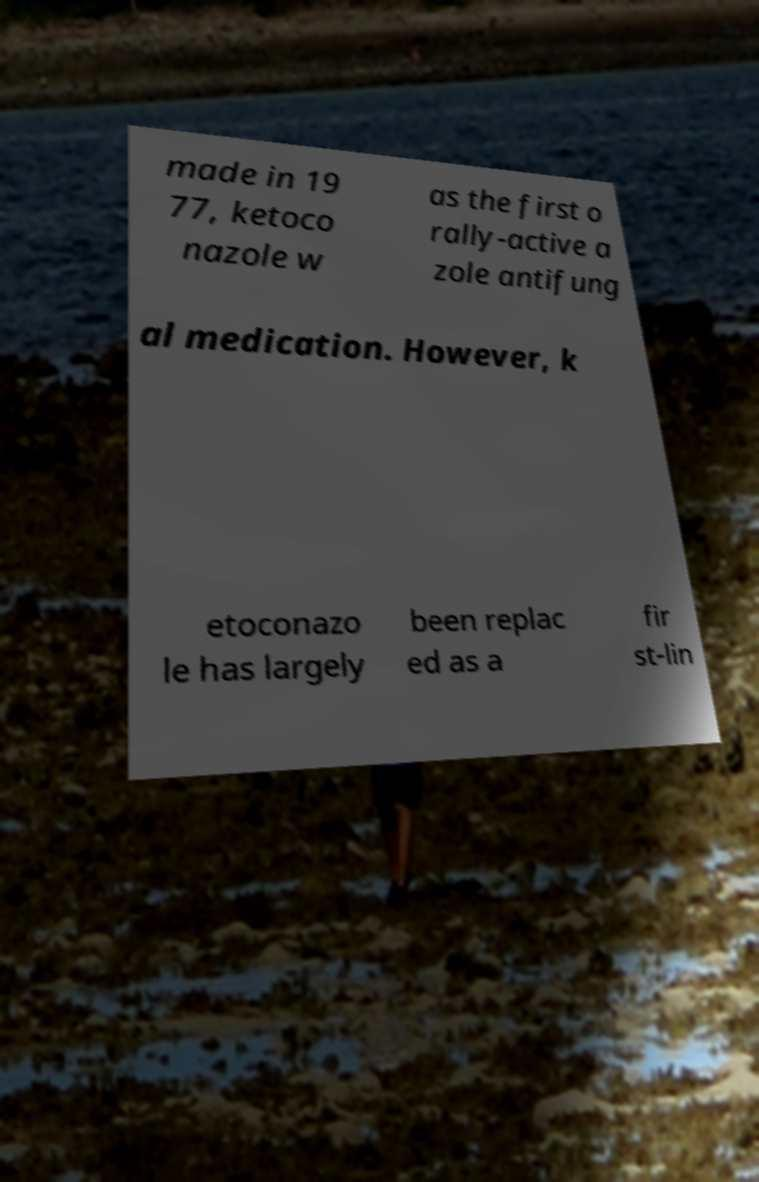What messages or text are displayed in this image? I need them in a readable, typed format. made in 19 77, ketoco nazole w as the first o rally-active a zole antifung al medication. However, k etoconazo le has largely been replac ed as a fir st-lin 